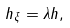<formula> <loc_0><loc_0><loc_500><loc_500>h _ { \xi } = \lambda h ,</formula> 